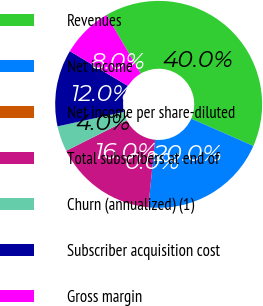Convert chart to OTSL. <chart><loc_0><loc_0><loc_500><loc_500><pie_chart><fcel>Revenues<fcel>Net income<fcel>Net income per share-diluted<fcel>Total subscribers at end of<fcel>Churn (annualized) (1)<fcel>Subscriber acquisition cost<fcel>Gross margin<nl><fcel>40.0%<fcel>20.0%<fcel>0.0%<fcel>16.0%<fcel>4.0%<fcel>12.0%<fcel>8.0%<nl></chart> 